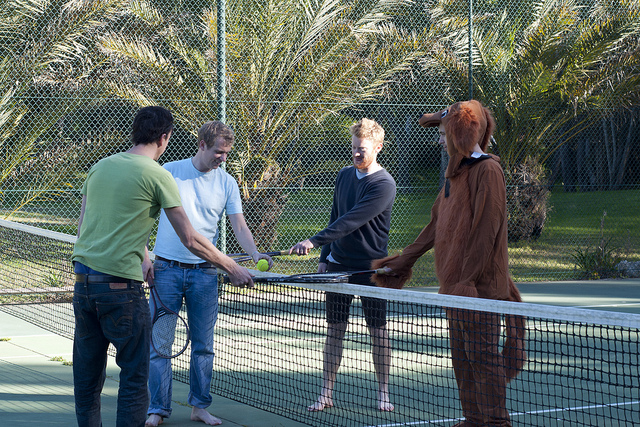Please provide a short description for this region: [0.22, 0.36, 0.42, 0.83]. A person wearing blue pants. 